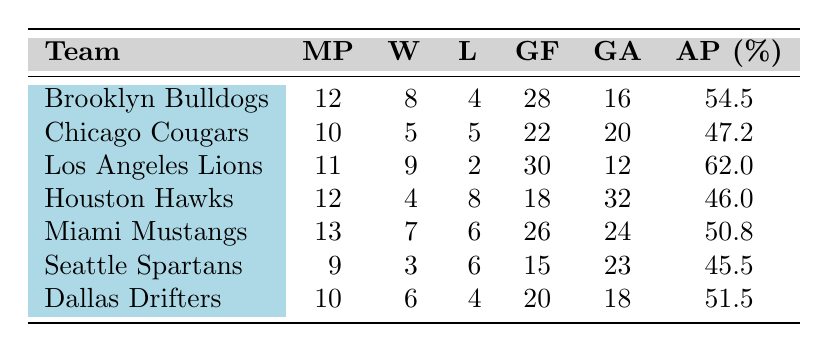What team has the highest average possession percentage? By reviewing the average possession percentages in the table, the Los Angeles Lions have the highest value at 62.0%.
Answer: Los Angeles Lions How many teams have won more than six matches? By counting the wins in the table, the Brooklyn Bulldogs (8), Los Angeles Lions (9), and Dallas Drifters (6) have won more than six matches, totaling three teams.
Answer: 3 What is the total number of goals scored by all teams? By adding the goals for each team: 28 (Brooklyn Bulldogs) + 22 (Chicago Cougars) + 30 (Los Angeles Lions) + 18 (Houston Hawks) + 26 (Miami Mustangs) + 15 (Seattle Spartans) + 20 (Dallas Drifters) = 169 total goals.
Answer: 169 Which team has the least number of wins? Looking at the wins column, the Houston Hawks have the least number of wins at 4.
Answer: Houston Hawks Do any teams have more red cards than yellow cards? Examining the red cards and yellow cards, the Houston Hawks (5 red, 25 yellow) and Seattle Spartans (4 red, 20 yellow) both have more yellow than red cards. No team has more red than yellow cards.
Answer: No What is the difference in goals against between the team with the highest and lowest goals against? The team with the highest goals against is the Houston Hawks with 32, and the lowest is the Los Angeles Lions with 12. The difference is 32 - 12 = 20.
Answer: 20 What is the average number of matches played among all teams? There are seven teams with a total of matches played being 12 + 10 + 11 + 12 + 13 + 9 + 10 = 87. Since there are 7 teams, the average is 87 / 7 = 12.43.
Answer: 12.43 Which team has the best win-loss ratio? To find this, calculate the win-loss ratio for each team: Brooklyn Bulldogs (8/4 = 2.0), Los Angeles Lions (9/2 = 4.5), Chicago Cougars (5/5 = 1.0), and so forth. The Los Angeles Lions have the best ratio at 4.5.
Answer: Los Angeles Lions 